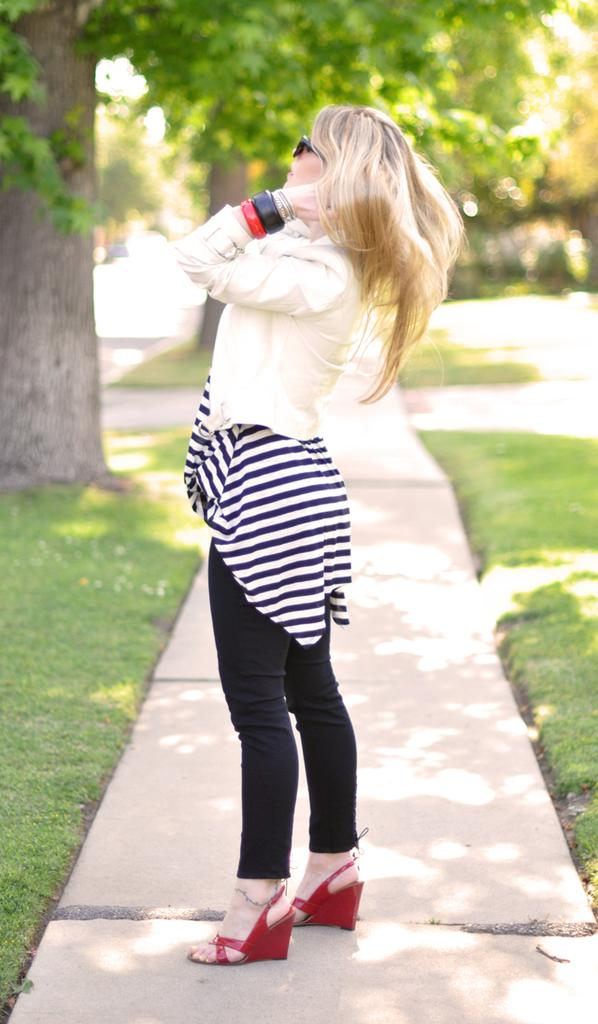Who is the main subject in the image? There is a woman in the image. What is the woman doing in the image? The woman is standing. What is the woman wearing on her upper body? The woman is wearing a white top. What is the woman wearing on her lower body? The woman is wearing black trousers. What can be seen on the left side of the image? There are trees on the left side of the image. What type of pet is the woman holding in the image? There is no pet visible in the image. Who is the parent of the woman in the image? The provided facts do not mention any information about the woman's parents. 